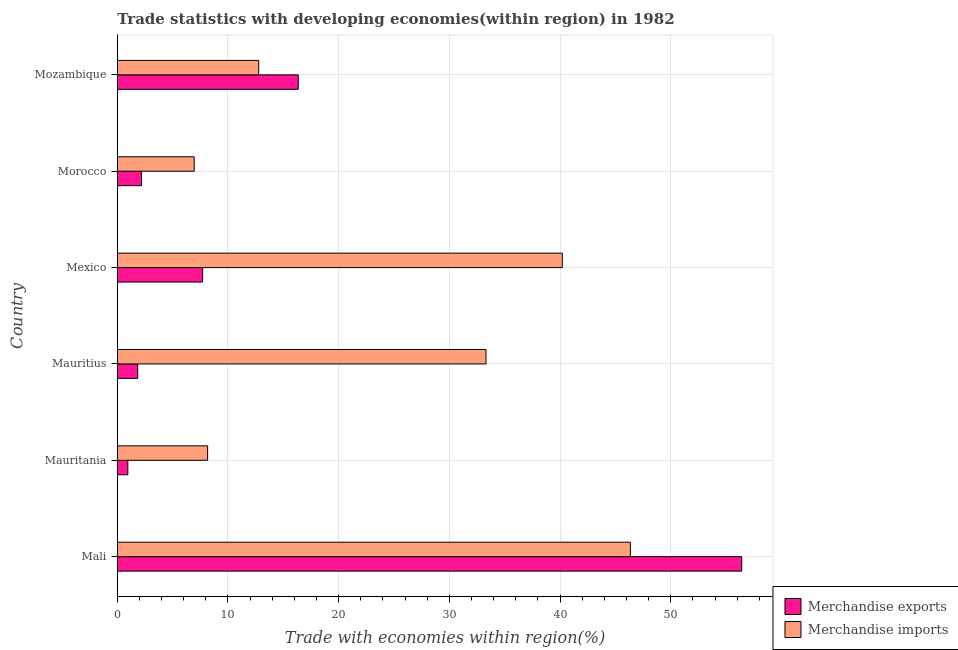How many groups of bars are there?
Your answer should be very brief. 6. Are the number of bars per tick equal to the number of legend labels?
Provide a succinct answer. Yes. Are the number of bars on each tick of the Y-axis equal?
Offer a very short reply. Yes. How many bars are there on the 3rd tick from the bottom?
Ensure brevity in your answer.  2. In how many cases, is the number of bars for a given country not equal to the number of legend labels?
Your answer should be compact. 0. What is the merchandise exports in Mauritania?
Keep it short and to the point. 0.95. Across all countries, what is the maximum merchandise imports?
Give a very brief answer. 46.35. Across all countries, what is the minimum merchandise imports?
Offer a terse response. 6.94. In which country was the merchandise imports maximum?
Provide a succinct answer. Mali. In which country was the merchandise imports minimum?
Your answer should be compact. Morocco. What is the total merchandise imports in the graph?
Provide a short and direct response. 147.73. What is the difference between the merchandise imports in Morocco and that in Mozambique?
Offer a terse response. -5.83. What is the difference between the merchandise imports in Mozambique and the merchandise exports in Morocco?
Provide a succinct answer. 10.58. What is the average merchandise imports per country?
Provide a short and direct response. 24.62. What is the difference between the merchandise exports and merchandise imports in Morocco?
Make the answer very short. -4.75. What is the ratio of the merchandise imports in Mauritania to that in Mauritius?
Provide a short and direct response. 0.24. Is the difference between the merchandise exports in Mauritius and Mexico greater than the difference between the merchandise imports in Mauritius and Mexico?
Offer a very short reply. Yes. What is the difference between the highest and the second highest merchandise exports?
Make the answer very short. 40.06. What is the difference between the highest and the lowest merchandise exports?
Provide a short and direct response. 55.45. Is the sum of the merchandise imports in Mauritius and Mexico greater than the maximum merchandise exports across all countries?
Provide a short and direct response. Yes. What does the 2nd bar from the top in Mozambique represents?
Your response must be concise. Merchandise exports. How many legend labels are there?
Give a very brief answer. 2. How are the legend labels stacked?
Provide a short and direct response. Vertical. What is the title of the graph?
Give a very brief answer. Trade statistics with developing economies(within region) in 1982. Does "Taxes on exports" appear as one of the legend labels in the graph?
Ensure brevity in your answer.  No. What is the label or title of the X-axis?
Ensure brevity in your answer.  Trade with economies within region(%). What is the label or title of the Y-axis?
Your answer should be compact. Country. What is the Trade with economies within region(%) of Merchandise exports in Mali?
Provide a short and direct response. 56.41. What is the Trade with economies within region(%) in Merchandise imports in Mali?
Make the answer very short. 46.35. What is the Trade with economies within region(%) of Merchandise exports in Mauritania?
Ensure brevity in your answer.  0.95. What is the Trade with economies within region(%) in Merchandise imports in Mauritania?
Keep it short and to the point. 8.16. What is the Trade with economies within region(%) in Merchandise exports in Mauritius?
Offer a very short reply. 1.85. What is the Trade with economies within region(%) of Merchandise imports in Mauritius?
Keep it short and to the point. 33.31. What is the Trade with economies within region(%) in Merchandise exports in Mexico?
Provide a short and direct response. 7.71. What is the Trade with economies within region(%) in Merchandise imports in Mexico?
Provide a short and direct response. 40.2. What is the Trade with economies within region(%) in Merchandise exports in Morocco?
Keep it short and to the point. 2.19. What is the Trade with economies within region(%) of Merchandise imports in Morocco?
Provide a succinct answer. 6.94. What is the Trade with economies within region(%) of Merchandise exports in Mozambique?
Offer a terse response. 16.35. What is the Trade with economies within region(%) of Merchandise imports in Mozambique?
Offer a terse response. 12.78. Across all countries, what is the maximum Trade with economies within region(%) in Merchandise exports?
Your answer should be very brief. 56.41. Across all countries, what is the maximum Trade with economies within region(%) in Merchandise imports?
Provide a short and direct response. 46.35. Across all countries, what is the minimum Trade with economies within region(%) of Merchandise exports?
Give a very brief answer. 0.95. Across all countries, what is the minimum Trade with economies within region(%) in Merchandise imports?
Make the answer very short. 6.94. What is the total Trade with economies within region(%) of Merchandise exports in the graph?
Give a very brief answer. 85.45. What is the total Trade with economies within region(%) in Merchandise imports in the graph?
Ensure brevity in your answer.  147.73. What is the difference between the Trade with economies within region(%) in Merchandise exports in Mali and that in Mauritania?
Your response must be concise. 55.45. What is the difference between the Trade with economies within region(%) of Merchandise imports in Mali and that in Mauritania?
Offer a terse response. 38.19. What is the difference between the Trade with economies within region(%) of Merchandise exports in Mali and that in Mauritius?
Provide a short and direct response. 54.56. What is the difference between the Trade with economies within region(%) of Merchandise imports in Mali and that in Mauritius?
Offer a terse response. 13.04. What is the difference between the Trade with economies within region(%) of Merchandise exports in Mali and that in Mexico?
Give a very brief answer. 48.7. What is the difference between the Trade with economies within region(%) of Merchandise imports in Mali and that in Mexico?
Your response must be concise. 6.15. What is the difference between the Trade with economies within region(%) in Merchandise exports in Mali and that in Morocco?
Your answer should be very brief. 54.22. What is the difference between the Trade with economies within region(%) in Merchandise imports in Mali and that in Morocco?
Keep it short and to the point. 39.4. What is the difference between the Trade with economies within region(%) in Merchandise exports in Mali and that in Mozambique?
Your response must be concise. 40.06. What is the difference between the Trade with economies within region(%) of Merchandise imports in Mali and that in Mozambique?
Keep it short and to the point. 33.57. What is the difference between the Trade with economies within region(%) in Merchandise exports in Mauritania and that in Mauritius?
Ensure brevity in your answer.  -0.89. What is the difference between the Trade with economies within region(%) in Merchandise imports in Mauritania and that in Mauritius?
Offer a terse response. -25.15. What is the difference between the Trade with economies within region(%) in Merchandise exports in Mauritania and that in Mexico?
Give a very brief answer. -6.75. What is the difference between the Trade with economies within region(%) of Merchandise imports in Mauritania and that in Mexico?
Offer a terse response. -32.04. What is the difference between the Trade with economies within region(%) of Merchandise exports in Mauritania and that in Morocco?
Your answer should be very brief. -1.24. What is the difference between the Trade with economies within region(%) in Merchandise imports in Mauritania and that in Morocco?
Offer a terse response. 1.21. What is the difference between the Trade with economies within region(%) of Merchandise exports in Mauritania and that in Mozambique?
Provide a succinct answer. -15.39. What is the difference between the Trade with economies within region(%) in Merchandise imports in Mauritania and that in Mozambique?
Your response must be concise. -4.62. What is the difference between the Trade with economies within region(%) of Merchandise exports in Mauritius and that in Mexico?
Your response must be concise. -5.86. What is the difference between the Trade with economies within region(%) of Merchandise imports in Mauritius and that in Mexico?
Offer a very short reply. -6.89. What is the difference between the Trade with economies within region(%) in Merchandise exports in Mauritius and that in Morocco?
Provide a succinct answer. -0.35. What is the difference between the Trade with economies within region(%) in Merchandise imports in Mauritius and that in Morocco?
Offer a terse response. 26.36. What is the difference between the Trade with economies within region(%) in Merchandise exports in Mauritius and that in Mozambique?
Your response must be concise. -14.5. What is the difference between the Trade with economies within region(%) in Merchandise imports in Mauritius and that in Mozambique?
Your answer should be very brief. 20.53. What is the difference between the Trade with economies within region(%) in Merchandise exports in Mexico and that in Morocco?
Ensure brevity in your answer.  5.52. What is the difference between the Trade with economies within region(%) in Merchandise imports in Mexico and that in Morocco?
Your response must be concise. 33.25. What is the difference between the Trade with economies within region(%) in Merchandise exports in Mexico and that in Mozambique?
Your answer should be compact. -8.64. What is the difference between the Trade with economies within region(%) in Merchandise imports in Mexico and that in Mozambique?
Keep it short and to the point. 27.42. What is the difference between the Trade with economies within region(%) of Merchandise exports in Morocco and that in Mozambique?
Make the answer very short. -14.15. What is the difference between the Trade with economies within region(%) in Merchandise imports in Morocco and that in Mozambique?
Offer a very short reply. -5.83. What is the difference between the Trade with economies within region(%) of Merchandise exports in Mali and the Trade with economies within region(%) of Merchandise imports in Mauritania?
Keep it short and to the point. 48.25. What is the difference between the Trade with economies within region(%) in Merchandise exports in Mali and the Trade with economies within region(%) in Merchandise imports in Mauritius?
Your answer should be very brief. 23.1. What is the difference between the Trade with economies within region(%) in Merchandise exports in Mali and the Trade with economies within region(%) in Merchandise imports in Mexico?
Your response must be concise. 16.21. What is the difference between the Trade with economies within region(%) of Merchandise exports in Mali and the Trade with economies within region(%) of Merchandise imports in Morocco?
Your response must be concise. 49.46. What is the difference between the Trade with economies within region(%) in Merchandise exports in Mali and the Trade with economies within region(%) in Merchandise imports in Mozambique?
Ensure brevity in your answer.  43.63. What is the difference between the Trade with economies within region(%) of Merchandise exports in Mauritania and the Trade with economies within region(%) of Merchandise imports in Mauritius?
Your answer should be very brief. -32.35. What is the difference between the Trade with economies within region(%) in Merchandise exports in Mauritania and the Trade with economies within region(%) in Merchandise imports in Mexico?
Keep it short and to the point. -39.24. What is the difference between the Trade with economies within region(%) of Merchandise exports in Mauritania and the Trade with economies within region(%) of Merchandise imports in Morocco?
Provide a short and direct response. -5.99. What is the difference between the Trade with economies within region(%) in Merchandise exports in Mauritania and the Trade with economies within region(%) in Merchandise imports in Mozambique?
Your answer should be very brief. -11.82. What is the difference between the Trade with economies within region(%) of Merchandise exports in Mauritius and the Trade with economies within region(%) of Merchandise imports in Mexico?
Offer a very short reply. -38.35. What is the difference between the Trade with economies within region(%) in Merchandise exports in Mauritius and the Trade with economies within region(%) in Merchandise imports in Morocco?
Offer a terse response. -5.1. What is the difference between the Trade with economies within region(%) of Merchandise exports in Mauritius and the Trade with economies within region(%) of Merchandise imports in Mozambique?
Offer a very short reply. -10.93. What is the difference between the Trade with economies within region(%) in Merchandise exports in Mexico and the Trade with economies within region(%) in Merchandise imports in Morocco?
Provide a short and direct response. 0.76. What is the difference between the Trade with economies within region(%) in Merchandise exports in Mexico and the Trade with economies within region(%) in Merchandise imports in Mozambique?
Provide a short and direct response. -5.07. What is the difference between the Trade with economies within region(%) of Merchandise exports in Morocco and the Trade with economies within region(%) of Merchandise imports in Mozambique?
Give a very brief answer. -10.58. What is the average Trade with economies within region(%) in Merchandise exports per country?
Provide a short and direct response. 14.24. What is the average Trade with economies within region(%) in Merchandise imports per country?
Your response must be concise. 24.62. What is the difference between the Trade with economies within region(%) of Merchandise exports and Trade with economies within region(%) of Merchandise imports in Mali?
Make the answer very short. 10.06. What is the difference between the Trade with economies within region(%) in Merchandise exports and Trade with economies within region(%) in Merchandise imports in Mauritania?
Your answer should be compact. -7.21. What is the difference between the Trade with economies within region(%) in Merchandise exports and Trade with economies within region(%) in Merchandise imports in Mauritius?
Keep it short and to the point. -31.46. What is the difference between the Trade with economies within region(%) in Merchandise exports and Trade with economies within region(%) in Merchandise imports in Mexico?
Make the answer very short. -32.49. What is the difference between the Trade with economies within region(%) of Merchandise exports and Trade with economies within region(%) of Merchandise imports in Morocco?
Your answer should be compact. -4.75. What is the difference between the Trade with economies within region(%) of Merchandise exports and Trade with economies within region(%) of Merchandise imports in Mozambique?
Give a very brief answer. 3.57. What is the ratio of the Trade with economies within region(%) of Merchandise exports in Mali to that in Mauritania?
Ensure brevity in your answer.  59.15. What is the ratio of the Trade with economies within region(%) of Merchandise imports in Mali to that in Mauritania?
Your answer should be very brief. 5.68. What is the ratio of the Trade with economies within region(%) in Merchandise exports in Mali to that in Mauritius?
Your answer should be very brief. 30.57. What is the ratio of the Trade with economies within region(%) of Merchandise imports in Mali to that in Mauritius?
Ensure brevity in your answer.  1.39. What is the ratio of the Trade with economies within region(%) of Merchandise exports in Mali to that in Mexico?
Your answer should be very brief. 7.32. What is the ratio of the Trade with economies within region(%) of Merchandise imports in Mali to that in Mexico?
Give a very brief answer. 1.15. What is the ratio of the Trade with economies within region(%) in Merchandise exports in Mali to that in Morocco?
Provide a short and direct response. 25.73. What is the ratio of the Trade with economies within region(%) in Merchandise imports in Mali to that in Morocco?
Your answer should be very brief. 6.67. What is the ratio of the Trade with economies within region(%) in Merchandise exports in Mali to that in Mozambique?
Give a very brief answer. 3.45. What is the ratio of the Trade with economies within region(%) of Merchandise imports in Mali to that in Mozambique?
Provide a short and direct response. 3.63. What is the ratio of the Trade with economies within region(%) in Merchandise exports in Mauritania to that in Mauritius?
Make the answer very short. 0.52. What is the ratio of the Trade with economies within region(%) of Merchandise imports in Mauritania to that in Mauritius?
Keep it short and to the point. 0.24. What is the ratio of the Trade with economies within region(%) in Merchandise exports in Mauritania to that in Mexico?
Ensure brevity in your answer.  0.12. What is the ratio of the Trade with economies within region(%) in Merchandise imports in Mauritania to that in Mexico?
Your response must be concise. 0.2. What is the ratio of the Trade with economies within region(%) of Merchandise exports in Mauritania to that in Morocco?
Offer a terse response. 0.43. What is the ratio of the Trade with economies within region(%) in Merchandise imports in Mauritania to that in Morocco?
Ensure brevity in your answer.  1.17. What is the ratio of the Trade with economies within region(%) of Merchandise exports in Mauritania to that in Mozambique?
Your answer should be very brief. 0.06. What is the ratio of the Trade with economies within region(%) in Merchandise imports in Mauritania to that in Mozambique?
Provide a succinct answer. 0.64. What is the ratio of the Trade with economies within region(%) of Merchandise exports in Mauritius to that in Mexico?
Make the answer very short. 0.24. What is the ratio of the Trade with economies within region(%) of Merchandise imports in Mauritius to that in Mexico?
Your answer should be compact. 0.83. What is the ratio of the Trade with economies within region(%) of Merchandise exports in Mauritius to that in Morocco?
Keep it short and to the point. 0.84. What is the ratio of the Trade with economies within region(%) in Merchandise imports in Mauritius to that in Morocco?
Keep it short and to the point. 4.8. What is the ratio of the Trade with economies within region(%) in Merchandise exports in Mauritius to that in Mozambique?
Your response must be concise. 0.11. What is the ratio of the Trade with economies within region(%) in Merchandise imports in Mauritius to that in Mozambique?
Ensure brevity in your answer.  2.61. What is the ratio of the Trade with economies within region(%) of Merchandise exports in Mexico to that in Morocco?
Offer a very short reply. 3.52. What is the ratio of the Trade with economies within region(%) of Merchandise imports in Mexico to that in Morocco?
Your answer should be very brief. 5.79. What is the ratio of the Trade with economies within region(%) in Merchandise exports in Mexico to that in Mozambique?
Provide a succinct answer. 0.47. What is the ratio of the Trade with economies within region(%) of Merchandise imports in Mexico to that in Mozambique?
Your response must be concise. 3.15. What is the ratio of the Trade with economies within region(%) of Merchandise exports in Morocco to that in Mozambique?
Make the answer very short. 0.13. What is the ratio of the Trade with economies within region(%) in Merchandise imports in Morocco to that in Mozambique?
Provide a succinct answer. 0.54. What is the difference between the highest and the second highest Trade with economies within region(%) of Merchandise exports?
Your response must be concise. 40.06. What is the difference between the highest and the second highest Trade with economies within region(%) in Merchandise imports?
Offer a very short reply. 6.15. What is the difference between the highest and the lowest Trade with economies within region(%) of Merchandise exports?
Offer a very short reply. 55.45. What is the difference between the highest and the lowest Trade with economies within region(%) of Merchandise imports?
Ensure brevity in your answer.  39.4. 